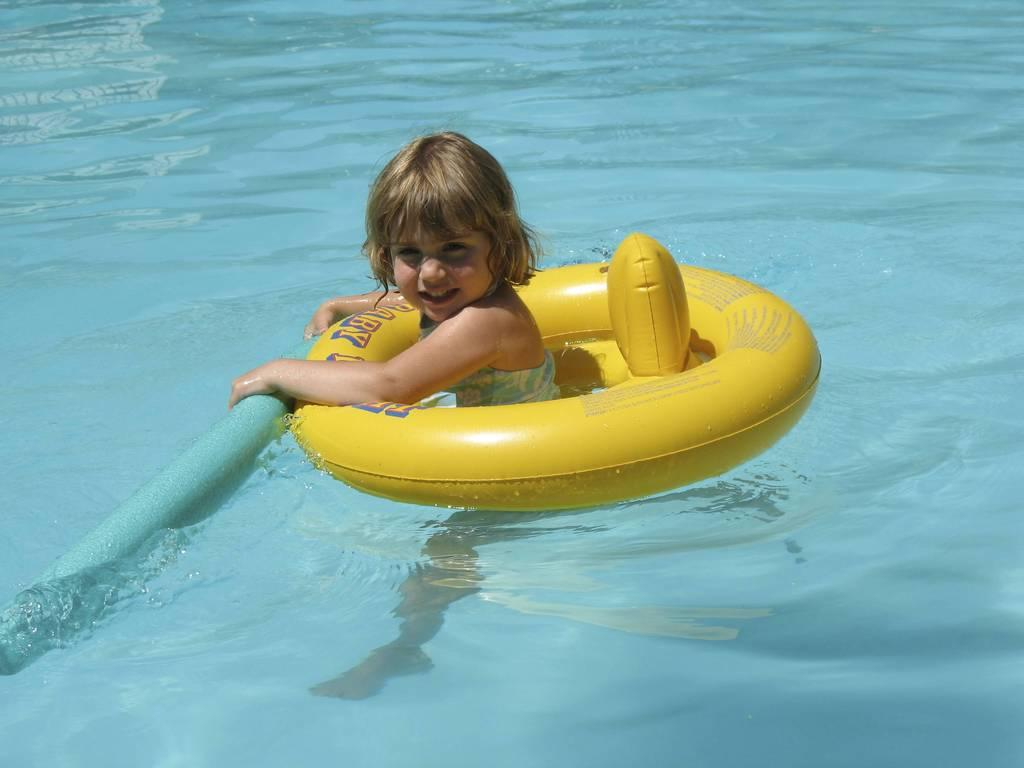What is the girl doing in the image? The girl is in the water. What is the color and type of object visible in the image? There is a yellow color object in the image. What is the color and shape of the other object in the image? There is a blue color rod in the image. What type of guitar is being played by the cattle in the image? There are no cattle or guitars present in the image. 